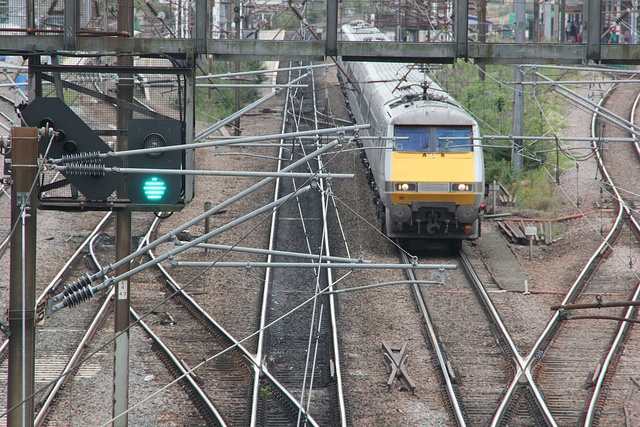Describe the objects in this image and their specific colors. I can see train in gray, darkgray, black, and lightgray tones, traffic light in gray, black, and darkgray tones, traffic light in gray, purple, darkblue, and black tones, people in gray and teal tones, and people in gray and darkblue tones in this image. 